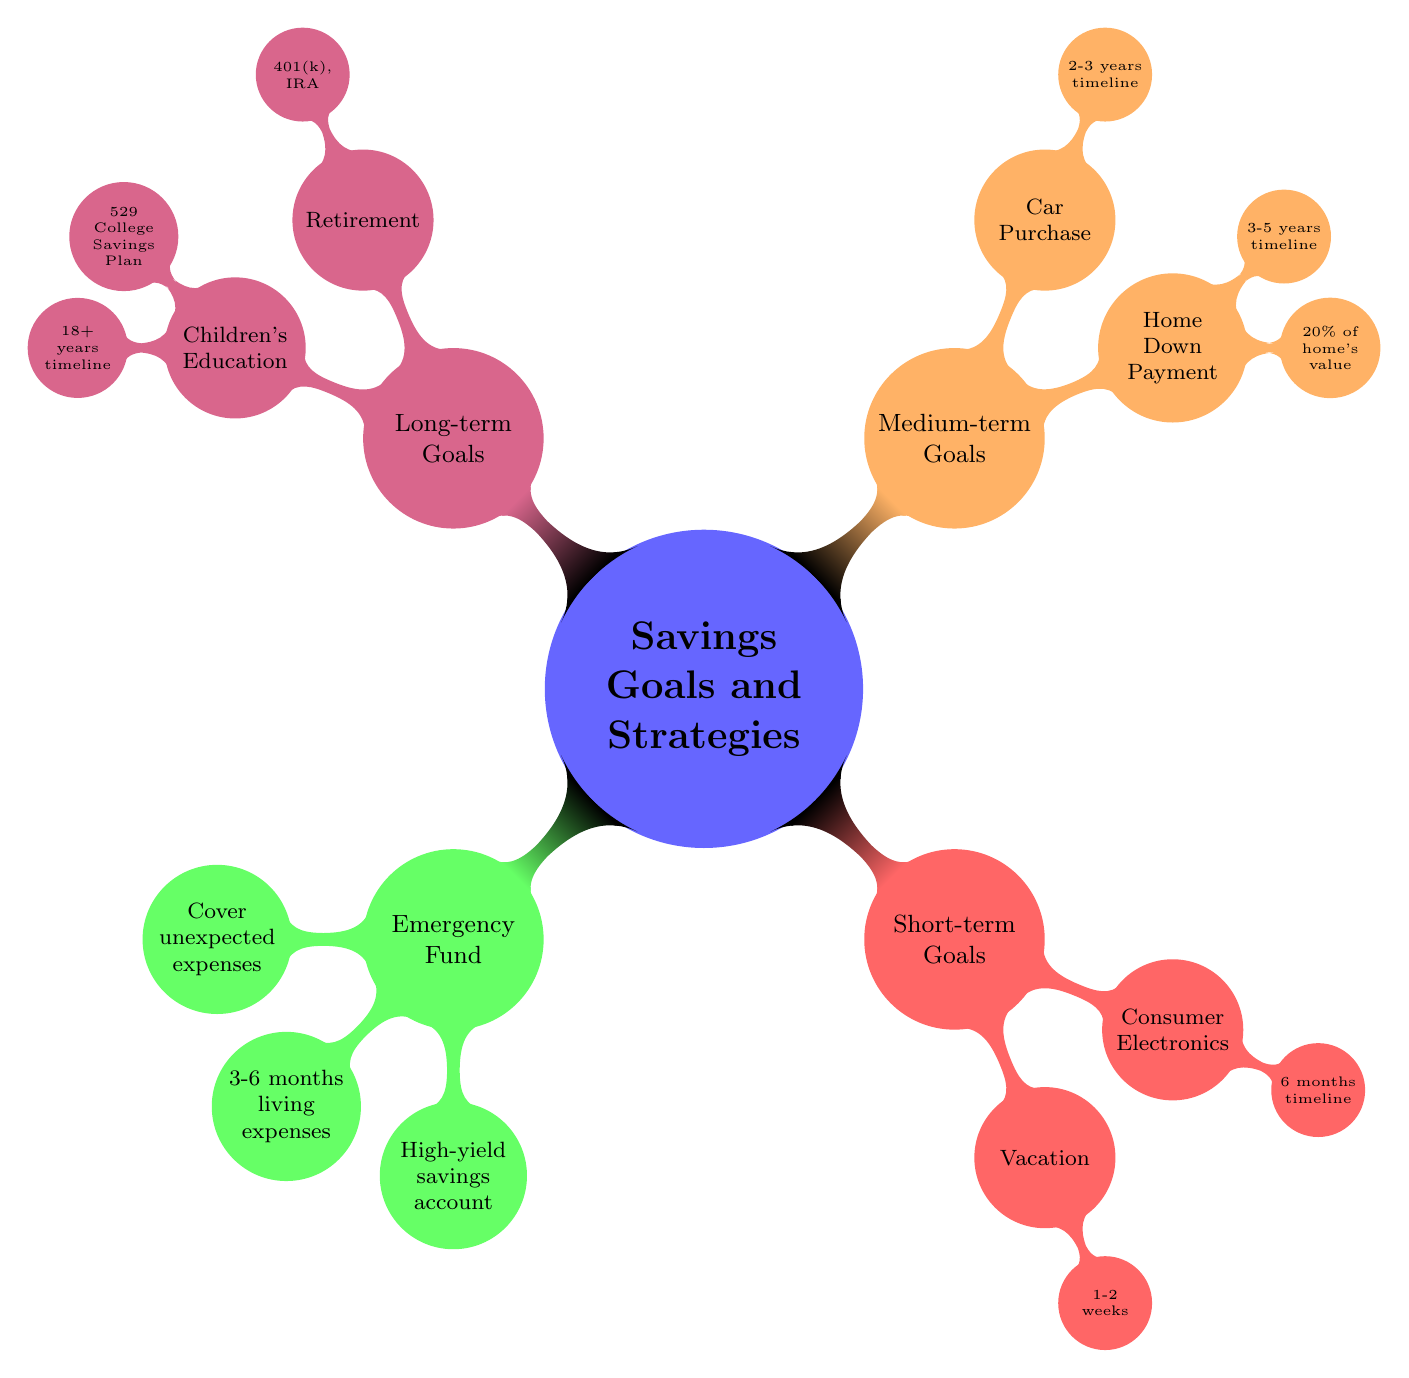What is the target amount for an Emergency Fund? The diagram states that the target amount for an Emergency Fund is 3-6 months of living expenses. This information is found directly under the Emergency Fund node.
Answer: 3-6 months of living expenses What is the account type recommended for an Emergency Fund? According to the diagram, the recommended account type for an Emergency Fund is a high-yield savings account. This is explicitly mentioned in the details under the Emergency Fund section.
Answer: High-yield savings account What is the timeline for saving towards a Home Down Payment? The diagram indicates that the timeline for saving towards a Home Down Payment is 3-5 years. This is specified under the Home Down Payment node in the Medium-term Goals section.
Answer: 3-5 years How many short-term goals are listed in the diagram? The diagram includes two short-term goals: Vacation and Consumer Electronics. By counting the nodes in the Short-term Goals section, we find there are two.
Answer: 2 What is the target account type for children's education savings? The diagram indicates that the account type for children's education savings is a 529 College Savings Plan. This information can be found under the Children's Education node.
Answer: 529 College Savings Plan Which goal has a savings plan involving automatic transfers? From the diagram, the goal that has a savings plan involving automatic transfers is the Home Down Payment. This is stated directly under the Home Down Payment node.
Answer: Home Down Payment Which goals fall under Medium-term Goals? The diagram shows that the Medium-term Goals include Home Down Payment and Car Purchase. By referencing the nodes under the Medium-term Goals section, these two can be identified.
Answer: Home Down Payment, Car Purchase What is the duration for the vacation goal? The diagram specifies that the duration for the vacation goal is 1-2 weeks. This information is included directly under the Vacation node in the Short-term Goals section.
Answer: 1-2 weeks What type of contributions are suggested for retirement savings? The diagram suggests that retirement savings should involve regular contributions and an employer match. This detail is clearly laid out in the Retirement node of the Long-term Goals section.
Answer: Regular contributions, employer match 